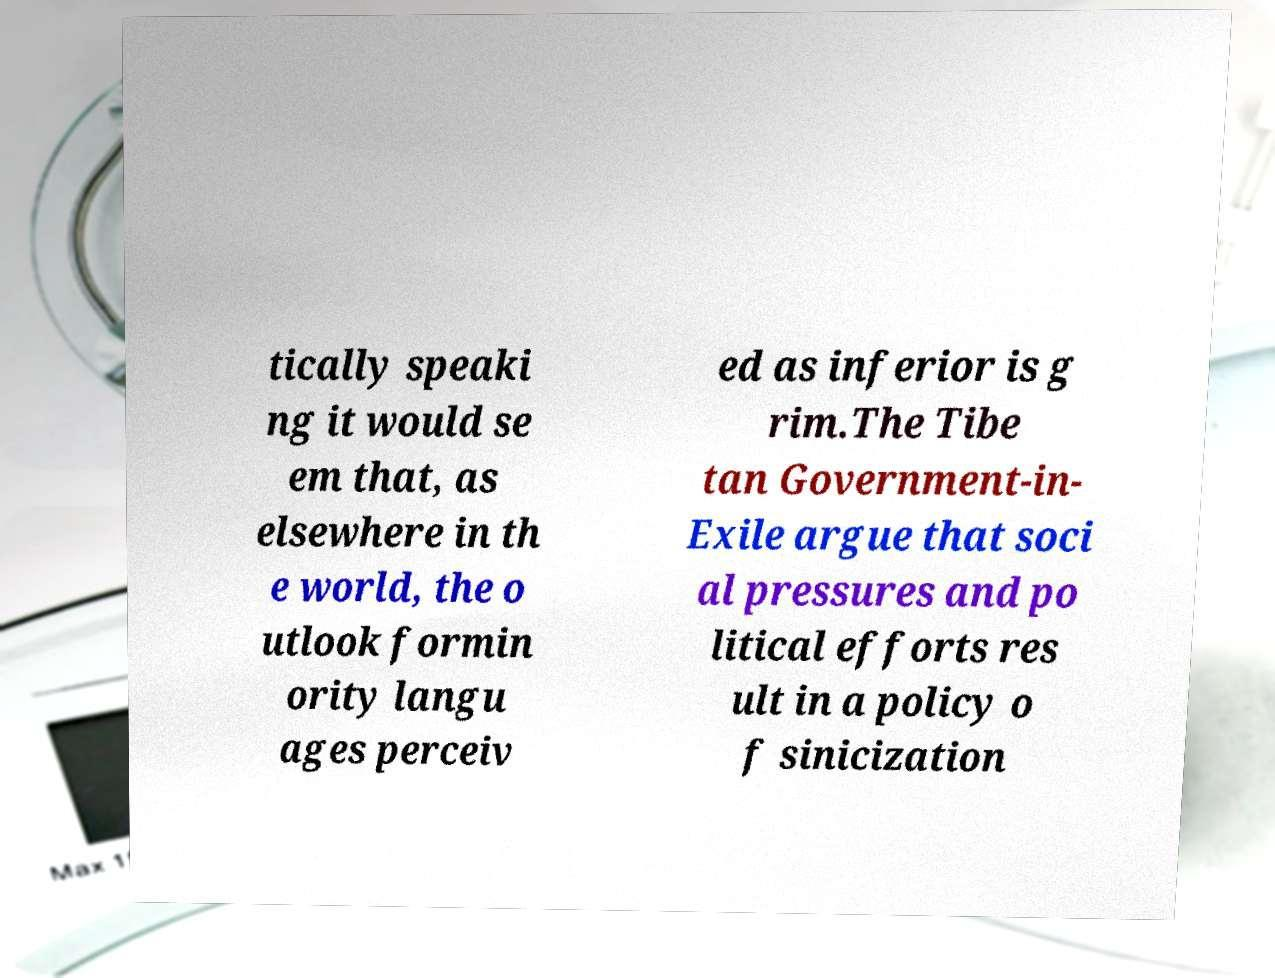For documentation purposes, I need the text within this image transcribed. Could you provide that? tically speaki ng it would se em that, as elsewhere in th e world, the o utlook formin ority langu ages perceiv ed as inferior is g rim.The Tibe tan Government-in- Exile argue that soci al pressures and po litical efforts res ult in a policy o f sinicization 